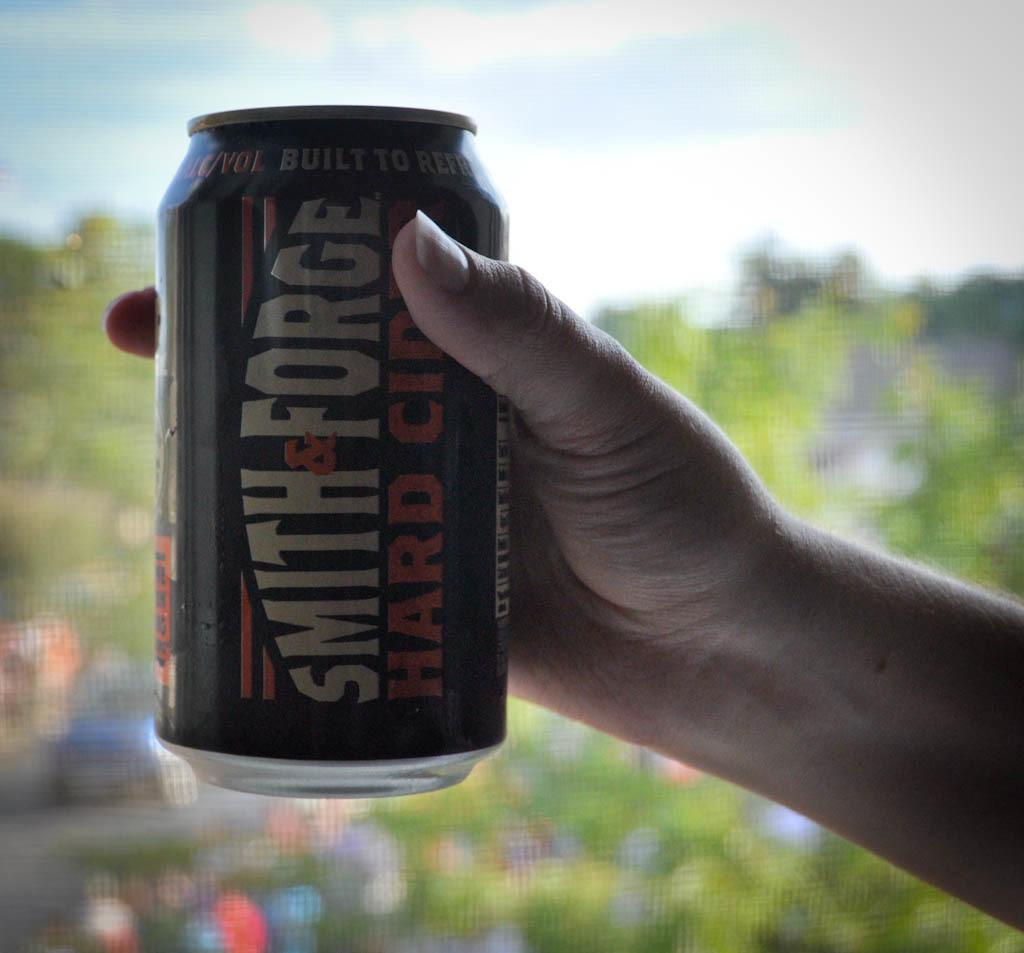What brand of hard cider?
Your answer should be very brief. Smith & forge. Is the word built on this can?
Ensure brevity in your answer.  Yes. 